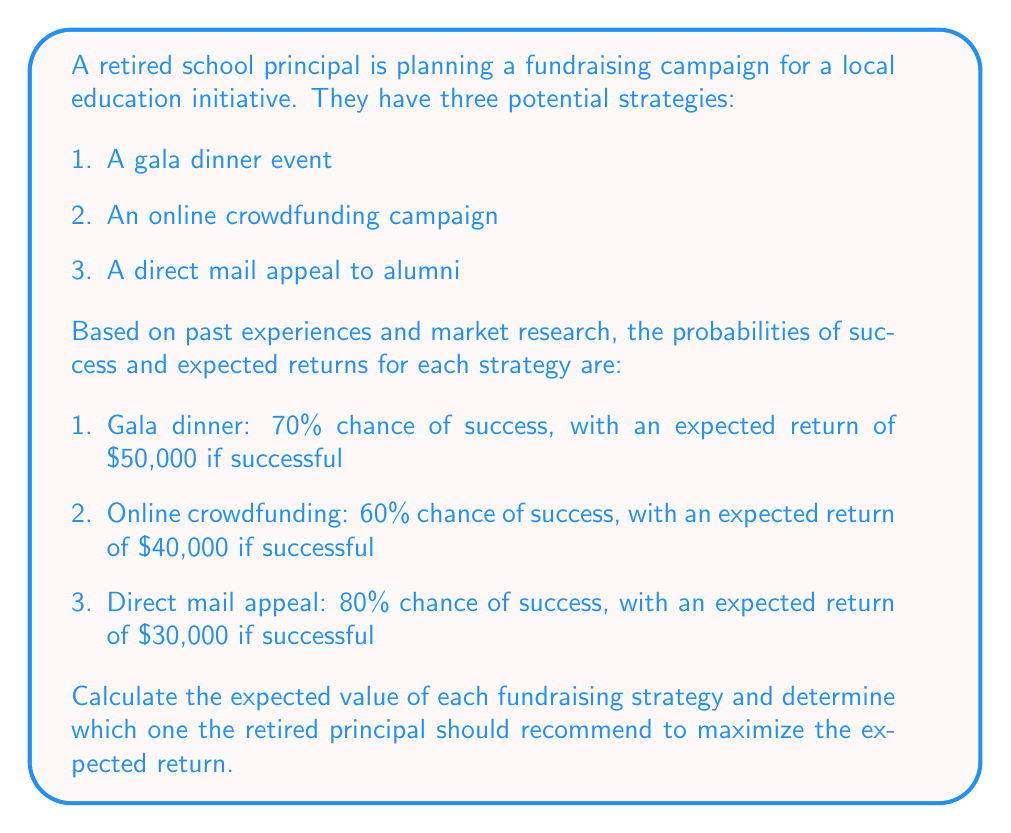Give your solution to this math problem. To solve this problem, we need to calculate the expected value of each fundraising strategy using the formula:

$$ E(X) = p(X) \cdot v(X) $$

Where:
$E(X)$ is the expected value
$p(X)$ is the probability of success
$v(X)$ is the value (return) if successful

Let's calculate the expected value for each strategy:

1. Gala dinner event:
$$ E(\text{Gala}) = 0.70 \cdot \$50,000 = \$35,000 $$

2. Online crowdfunding campaign:
$$ E(\text{Crowdfunding}) = 0.60 \cdot \$40,000 = \$24,000 $$

3. Direct mail appeal to alumni:
$$ E(\text{Direct mail}) = 0.80 \cdot \$30,000 = \$24,000 $$

To determine which strategy the retired principal should recommend, we compare the expected values:

$$ E(\text{Gala}) > E(\text{Crowdfunding}) = E(\text{Direct mail}) $$

$$ \$35,000 > \$24,000 = \$24,000 $$

The gala dinner event has the highest expected value, so it should be recommended to maximize the expected return.
Answer: The retired principal should recommend the gala dinner event strategy, as it has the highest expected value of $35,000. 